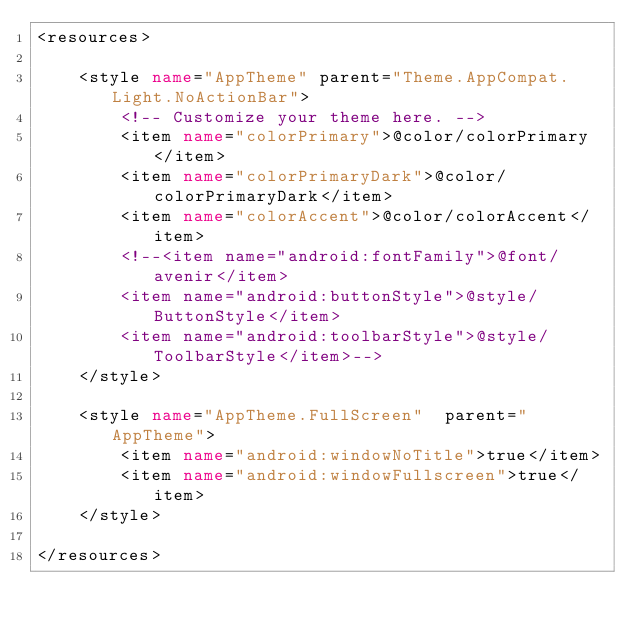Convert code to text. <code><loc_0><loc_0><loc_500><loc_500><_XML_><resources>

    <style name="AppTheme" parent="Theme.AppCompat.Light.NoActionBar">
        <!-- Customize your theme here. -->
        <item name="colorPrimary">@color/colorPrimary</item>
        <item name="colorPrimaryDark">@color/colorPrimaryDark</item>
        <item name="colorAccent">@color/colorAccent</item>
        <!--<item name="android:fontFamily">@font/avenir</item>
        <item name="android:buttonStyle">@style/ButtonStyle</item>
        <item name="android:toolbarStyle">@style/ToolbarStyle</item>-->
    </style>

    <style name="AppTheme.FullScreen"  parent="AppTheme">
        <item name="android:windowNoTitle">true</item>
        <item name="android:windowFullscreen">true</item>
    </style>

</resources>
</code> 